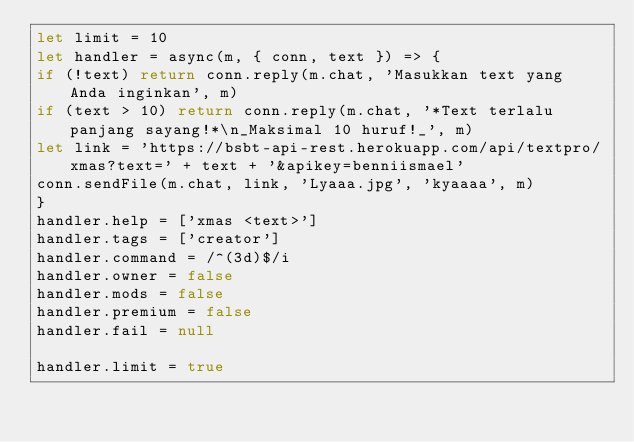<code> <loc_0><loc_0><loc_500><loc_500><_JavaScript_>let limit = 10
let handler = async(m, { conn, text }) => {
if (!text) return conn.reply(m.chat, 'Masukkan text yang Anda inginkan', m)
if (text > 10) return conn.reply(m.chat, '*Text terlalu panjang sayang!*\n_Maksimal 10 huruf!_', m)
let link = 'https://bsbt-api-rest.herokuapp.com/api/textpro/xmas?text=' + text + '&apikey=benniismael'
conn.sendFile(m.chat, link, 'Lyaaa.jpg', 'kyaaaa', m)
}
handler.help = ['xmas <text>']
handler.tags = ['creator']
handler.command = /^(3d)$/i
handler.owner = false
handler.mods = false
handler.premium = false
handler.fail = null

handler.limit = true</code> 